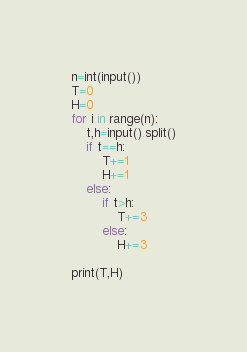<code> <loc_0><loc_0><loc_500><loc_500><_Python_>n=int(input())
T=0
H=0
for i in range(n):
    t,h=input().split()
    if t==h:
        T+=1
        H+=1
    else:
        if t>h:
            T+=3
        else:
            H+=3
    
print(T,H)
</code> 